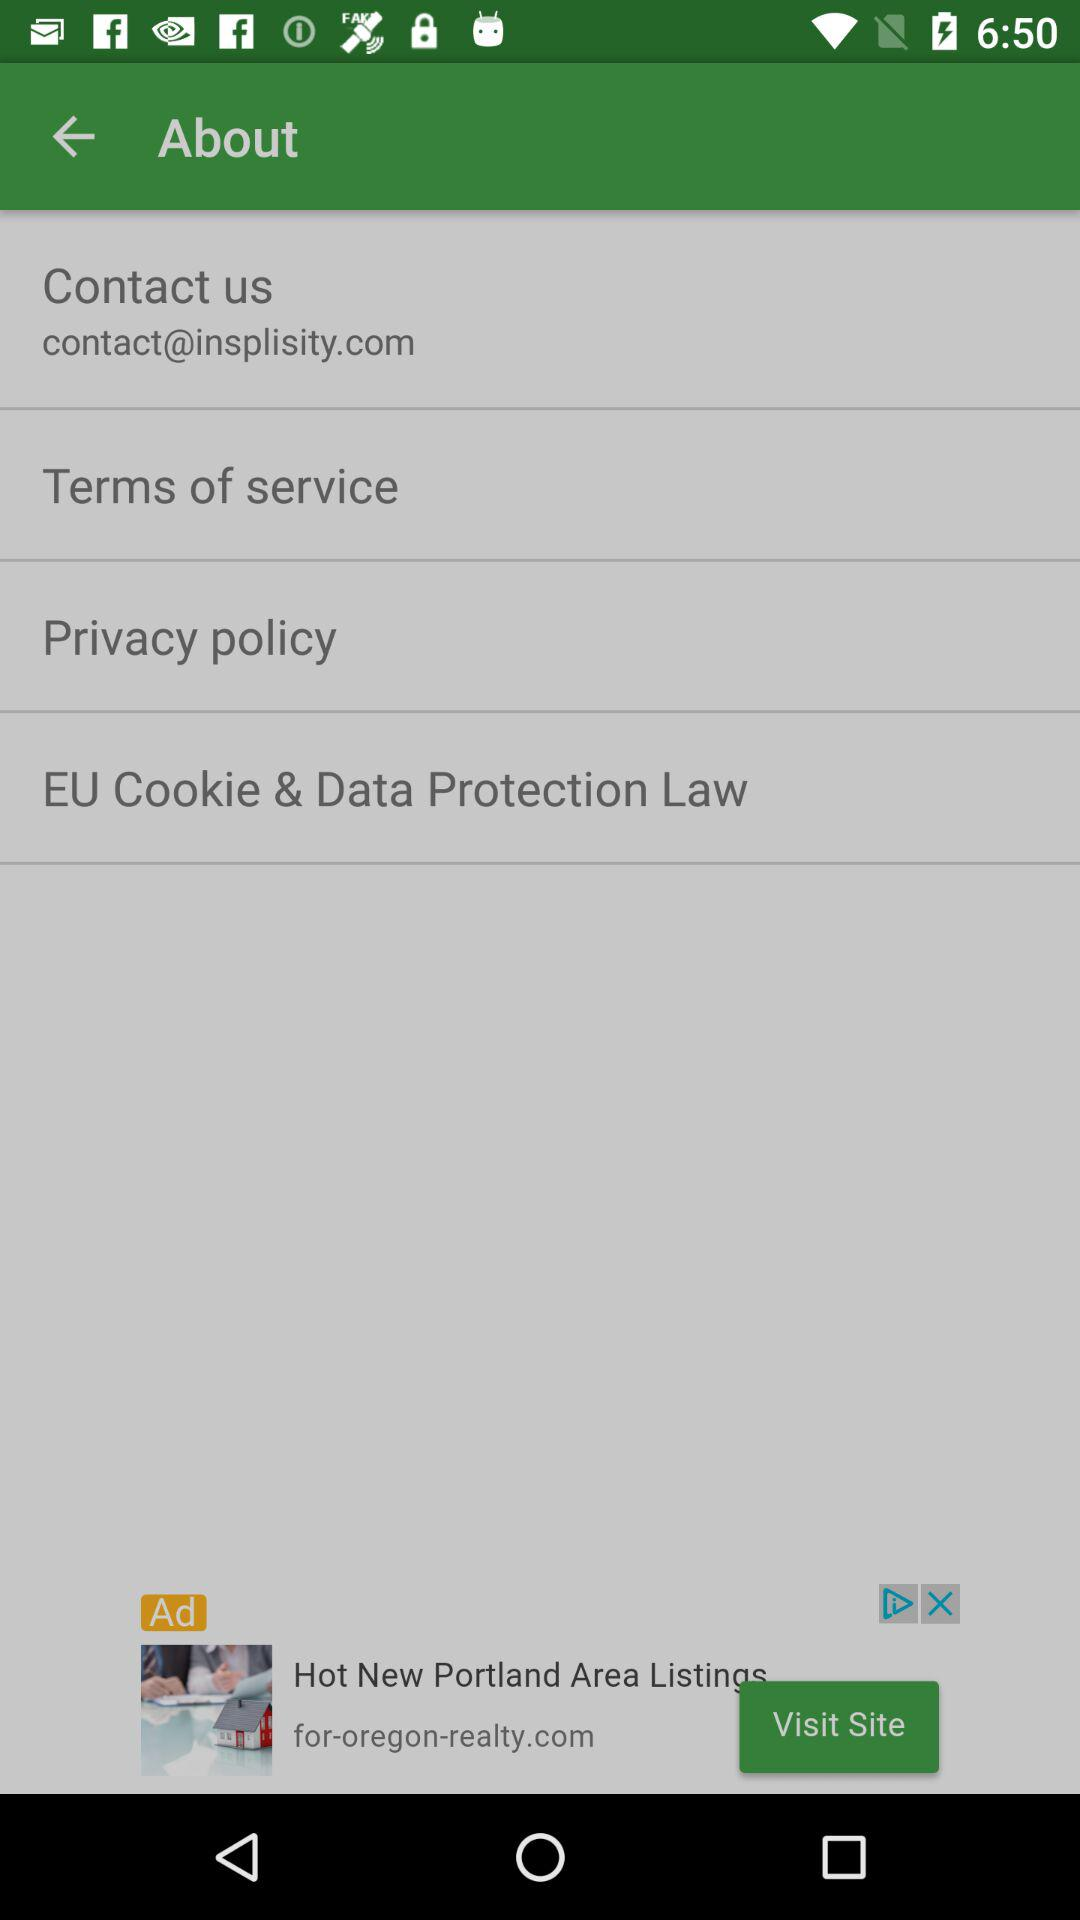What is the email address? The email address is contact@insplisity.com. 